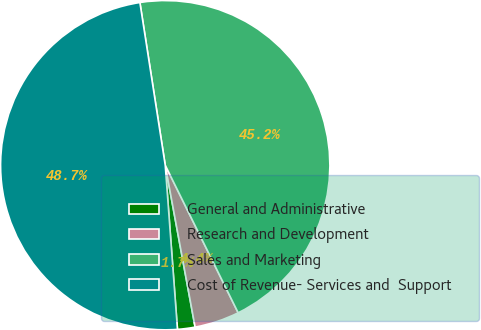Convert chart to OTSL. <chart><loc_0><loc_0><loc_500><loc_500><pie_chart><fcel>General and Administrative<fcel>Research and Development<fcel>Sales and Marketing<fcel>Cost of Revenue- Services and  Support<nl><fcel>1.72%<fcel>4.4%<fcel>45.15%<fcel>48.72%<nl></chart> 